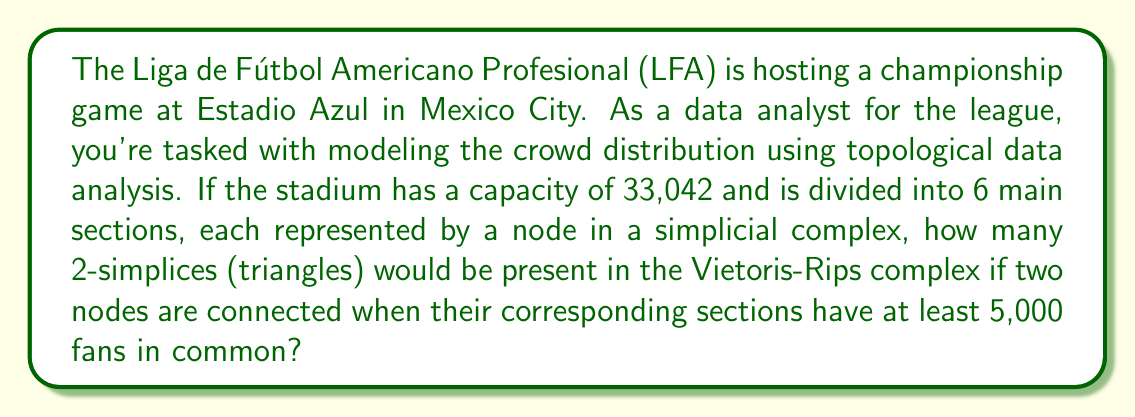Teach me how to tackle this problem. To solve this problem, we need to understand the concept of Vietoris-Rips complex and apply it to the given scenario. Let's break it down step-by-step:

1) First, we need to determine how many fans are in each section on average:
   $$ \frac{33,042 \text{ fans}}{6 \text{ sections}} = 5,507 \text{ fans per section} $$

2) Now, we need to consider how many pairs of sections could have at least 5,000 fans in common. Given the average, it's reasonable to assume that all adjacent sections would meet this criterion.

3) In a simplicial complex with 6 nodes representing the stadium sections, we can visualize this as a circular arrangement where each section is connected to its two adjacent sections.

4) In this arrangement, we would have 6 edges connecting the nodes in a circular pattern.

5) A 2-simplex (triangle) in the Vietoris-Rips complex would be formed when three nodes are mutually connected, meaning that all three corresponding sections have at least 5,000 fans in common with each other.

6) In our circular arrangement, every set of three consecutive sections would form a triangle. There are 6 such sets in total.

7) Therefore, the number of 2-simplices (triangles) in the Vietoris-Rips complex would be 6.

This topological representation allows us to model the crowd distribution and understand the connectivity between different sections of the stadium based on shared attendance.
Answer: 6 2-simplices (triangles) 